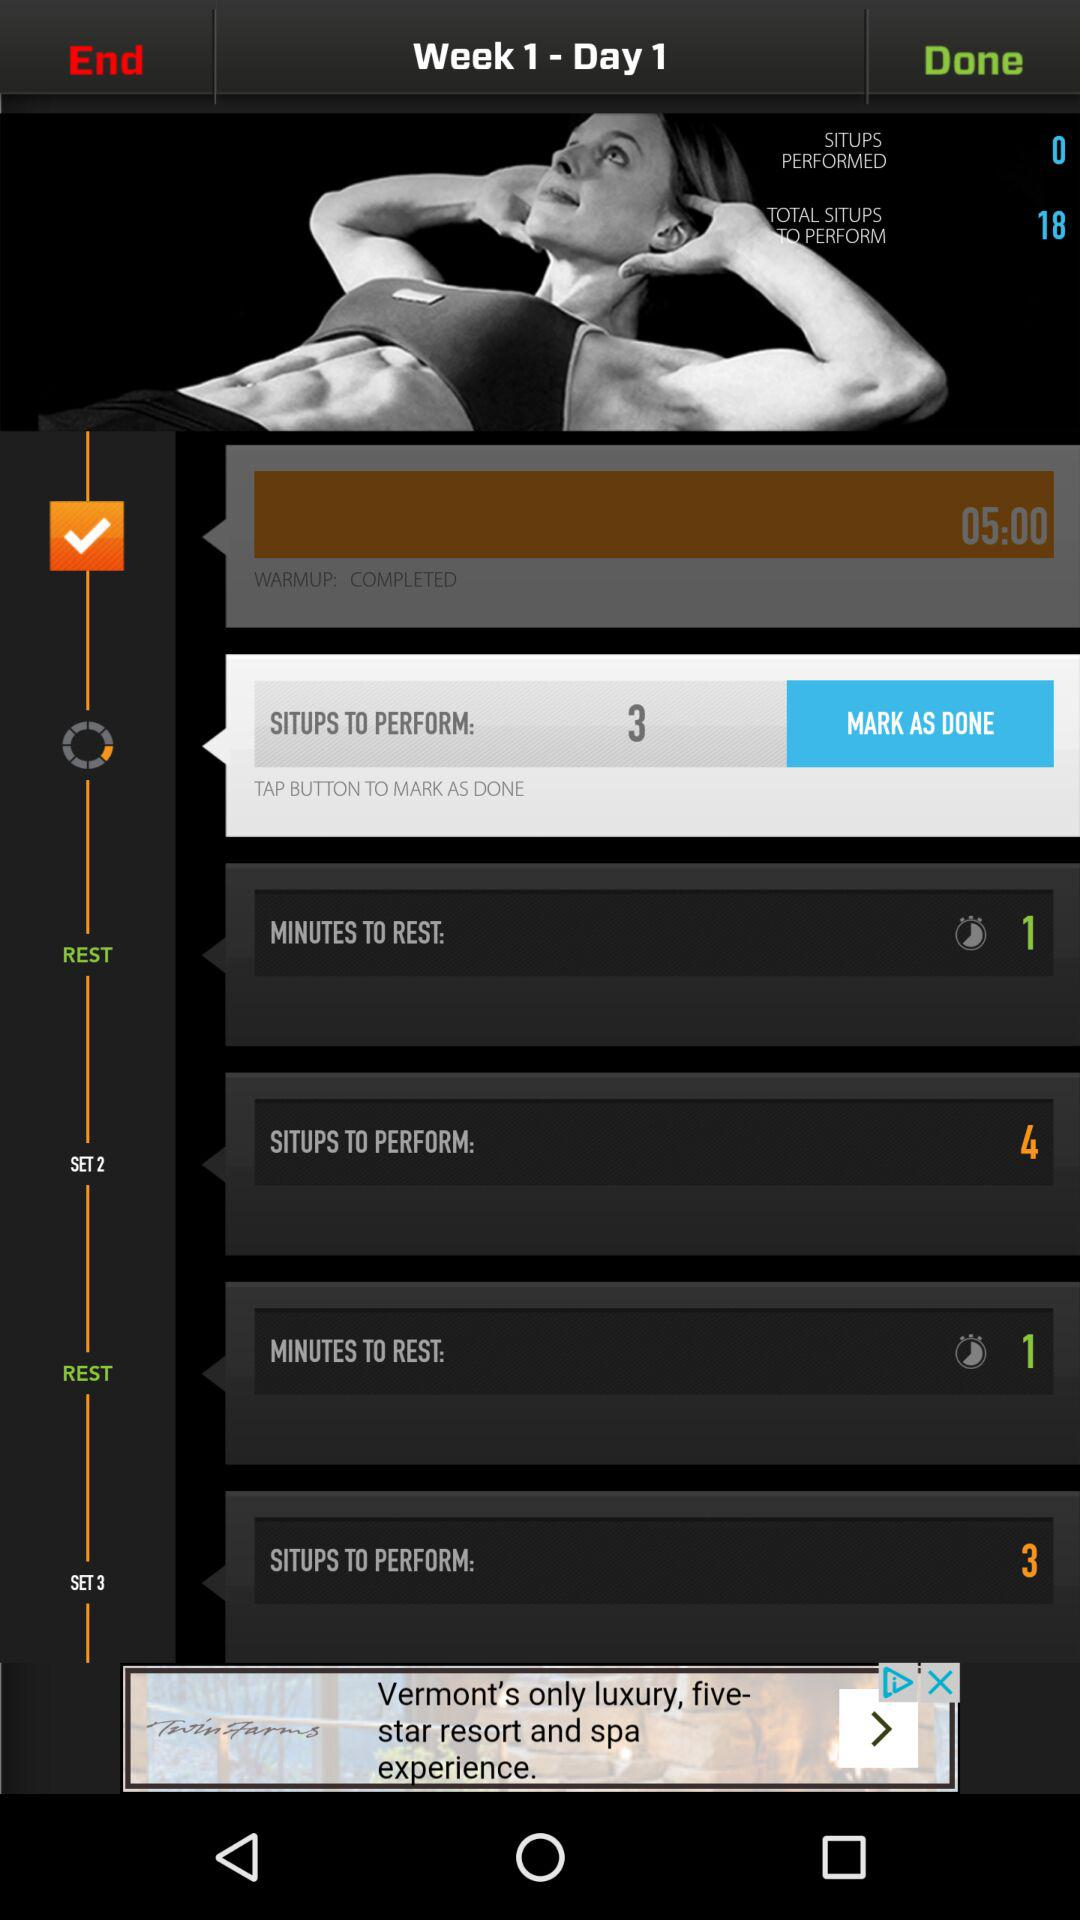How many situps are there to perform in Set 1? There are 3 situps to perform in Set 1. 